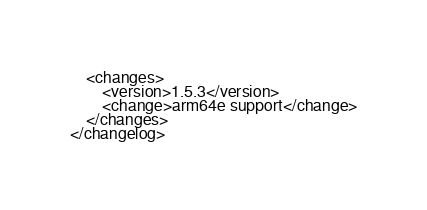<code> <loc_0><loc_0><loc_500><loc_500><_XML_>    <changes>
        <version>1.5.3</version>
        <change>arm64e support</change>
    </changes>
</changelog>
</code> 